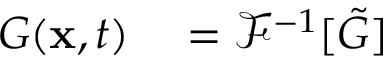<formula> <loc_0><loc_0><loc_500><loc_500>\begin{array} { r l } { G ( x , t ) } & = \mathcal { F } ^ { - 1 } [ \tilde { G } ] } \end{array}</formula> 